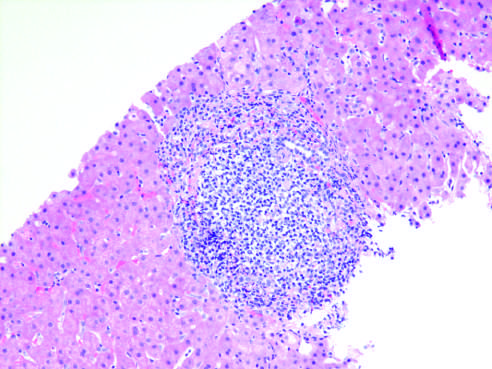what shows characteristic portal tract expansion by a dense lymphoid infiltrate?
Answer the question using a single word or phrase. Chronic viral hepatitis due to hcv 